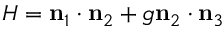Convert formula to latex. <formula><loc_0><loc_0><loc_500><loc_500>H = \mathbf n _ { 1 } \cdot \mathbf n _ { 2 } + g \mathbf n _ { 2 } \cdot \mathbf n _ { 3 }</formula> 